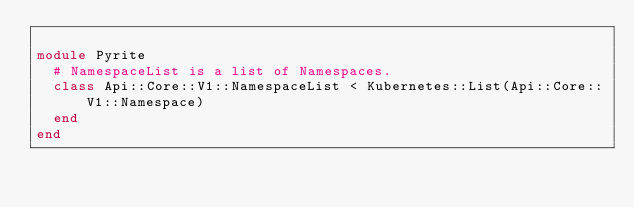Convert code to text. <code><loc_0><loc_0><loc_500><loc_500><_Crystal_>
module Pyrite
  # NamespaceList is a list of Namespaces.
  class Api::Core::V1::NamespaceList < Kubernetes::List(Api::Core::V1::Namespace)
  end
end
</code> 